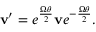<formula> <loc_0><loc_0><loc_500><loc_500>v ^ { \prime } = e ^ { \frac { { \Omega } \theta } { 2 } } v e ^ { - { \frac { { \Omega } \theta } { 2 } } } .</formula> 